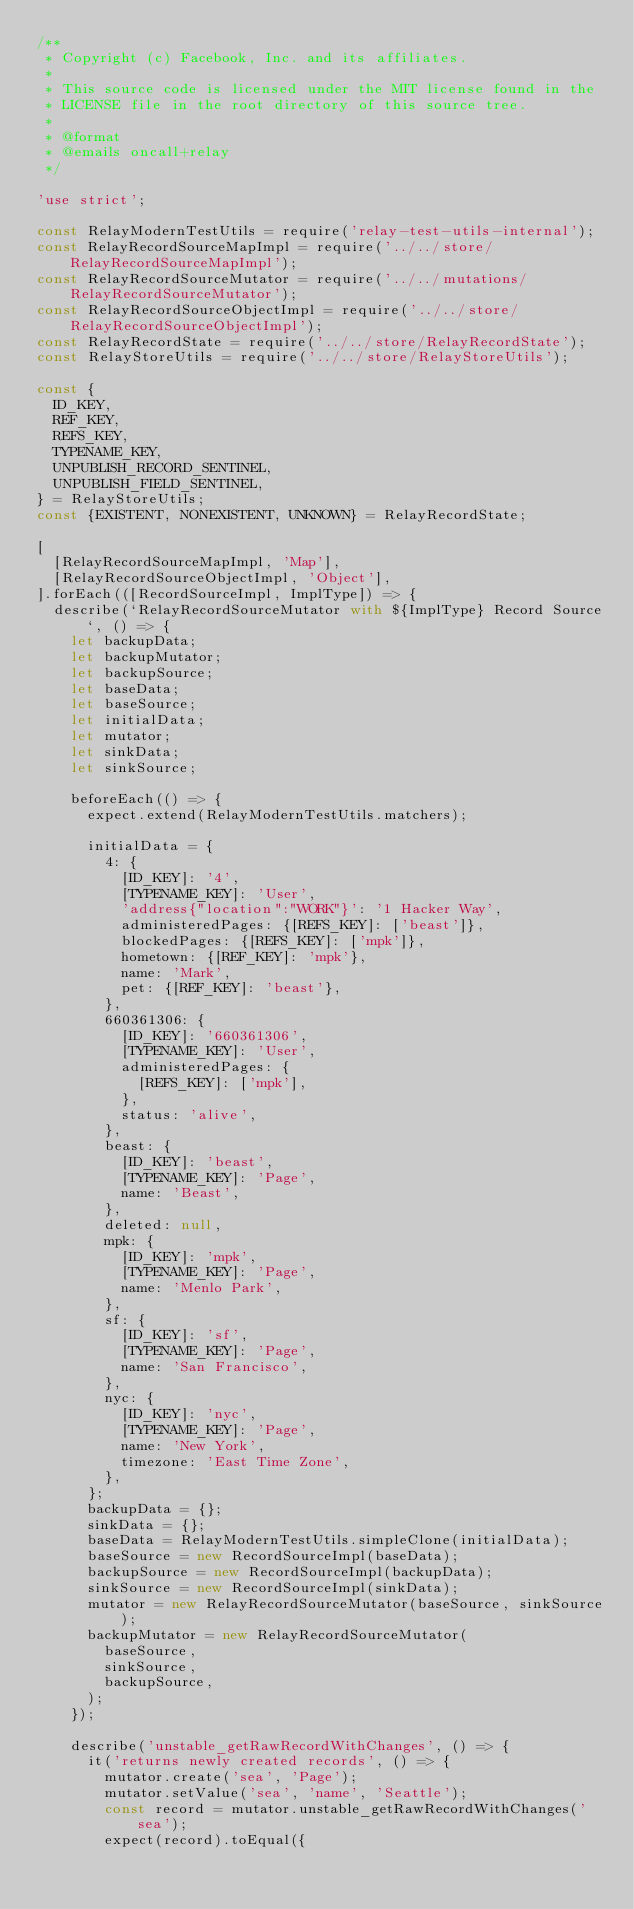<code> <loc_0><loc_0><loc_500><loc_500><_JavaScript_>/**
 * Copyright (c) Facebook, Inc. and its affiliates.
 *
 * This source code is licensed under the MIT license found in the
 * LICENSE file in the root directory of this source tree.
 *
 * @format
 * @emails oncall+relay
 */

'use strict';

const RelayModernTestUtils = require('relay-test-utils-internal');
const RelayRecordSourceMapImpl = require('../../store/RelayRecordSourceMapImpl');
const RelayRecordSourceMutator = require('../../mutations/RelayRecordSourceMutator');
const RelayRecordSourceObjectImpl = require('../../store/RelayRecordSourceObjectImpl');
const RelayRecordState = require('../../store/RelayRecordState');
const RelayStoreUtils = require('../../store/RelayStoreUtils');

const {
  ID_KEY,
  REF_KEY,
  REFS_KEY,
  TYPENAME_KEY,
  UNPUBLISH_RECORD_SENTINEL,
  UNPUBLISH_FIELD_SENTINEL,
} = RelayStoreUtils;
const {EXISTENT, NONEXISTENT, UNKNOWN} = RelayRecordState;

[
  [RelayRecordSourceMapImpl, 'Map'],
  [RelayRecordSourceObjectImpl, 'Object'],
].forEach(([RecordSourceImpl, ImplType]) => {
  describe(`RelayRecordSourceMutator with ${ImplType} Record Source`, () => {
    let backupData;
    let backupMutator;
    let backupSource;
    let baseData;
    let baseSource;
    let initialData;
    let mutator;
    let sinkData;
    let sinkSource;

    beforeEach(() => {
      expect.extend(RelayModernTestUtils.matchers);

      initialData = {
        4: {
          [ID_KEY]: '4',
          [TYPENAME_KEY]: 'User',
          'address{"location":"WORK"}': '1 Hacker Way',
          administeredPages: {[REFS_KEY]: ['beast']},
          blockedPages: {[REFS_KEY]: ['mpk']},
          hometown: {[REF_KEY]: 'mpk'},
          name: 'Mark',
          pet: {[REF_KEY]: 'beast'},
        },
        660361306: {
          [ID_KEY]: '660361306',
          [TYPENAME_KEY]: 'User',
          administeredPages: {
            [REFS_KEY]: ['mpk'],
          },
          status: 'alive',
        },
        beast: {
          [ID_KEY]: 'beast',
          [TYPENAME_KEY]: 'Page',
          name: 'Beast',
        },
        deleted: null,
        mpk: {
          [ID_KEY]: 'mpk',
          [TYPENAME_KEY]: 'Page',
          name: 'Menlo Park',
        },
        sf: {
          [ID_KEY]: 'sf',
          [TYPENAME_KEY]: 'Page',
          name: 'San Francisco',
        },
        nyc: {
          [ID_KEY]: 'nyc',
          [TYPENAME_KEY]: 'Page',
          name: 'New York',
          timezone: 'East Time Zone',
        },
      };
      backupData = {};
      sinkData = {};
      baseData = RelayModernTestUtils.simpleClone(initialData);
      baseSource = new RecordSourceImpl(baseData);
      backupSource = new RecordSourceImpl(backupData);
      sinkSource = new RecordSourceImpl(sinkData);
      mutator = new RelayRecordSourceMutator(baseSource, sinkSource);
      backupMutator = new RelayRecordSourceMutator(
        baseSource,
        sinkSource,
        backupSource,
      );
    });

    describe('unstable_getRawRecordWithChanges', () => {
      it('returns newly created records', () => {
        mutator.create('sea', 'Page');
        mutator.setValue('sea', 'name', 'Seattle');
        const record = mutator.unstable_getRawRecordWithChanges('sea');
        expect(record).toEqual({</code> 